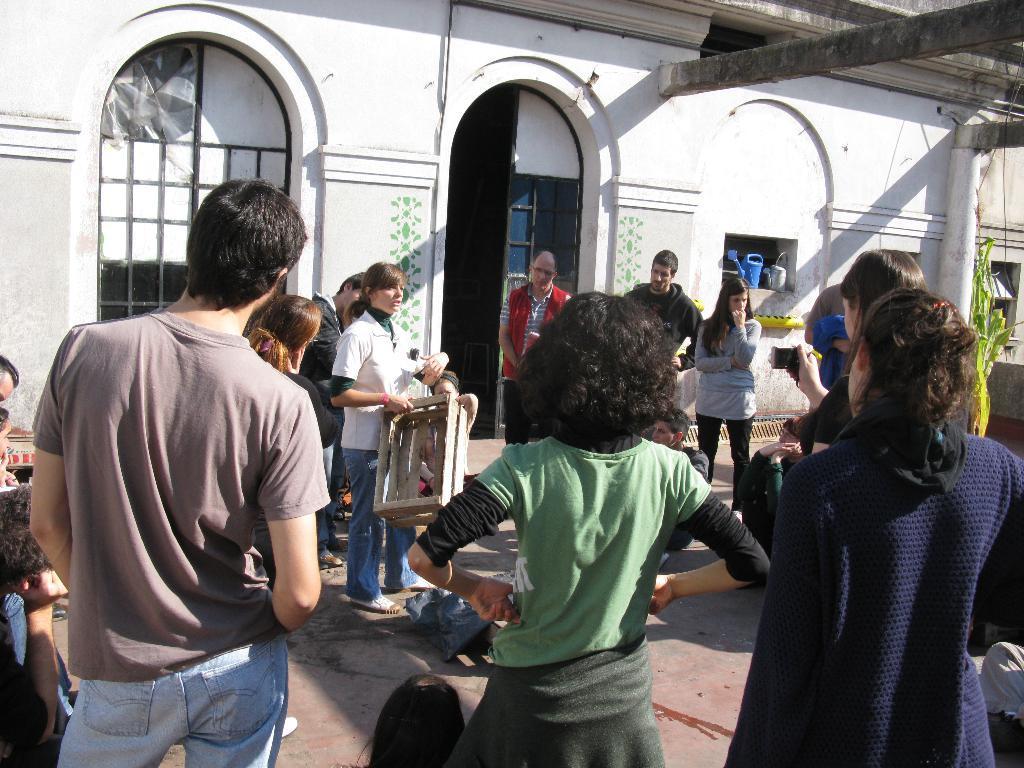Describe this image in one or two sentences. Here in this picture we can see number of people standing on the ground over there and in the middle we can see a woman holding something and performing, as the other people are watching and behind them we can see a building present and we can see a windows and door present over there, on the right side we can see a plant present over there. 